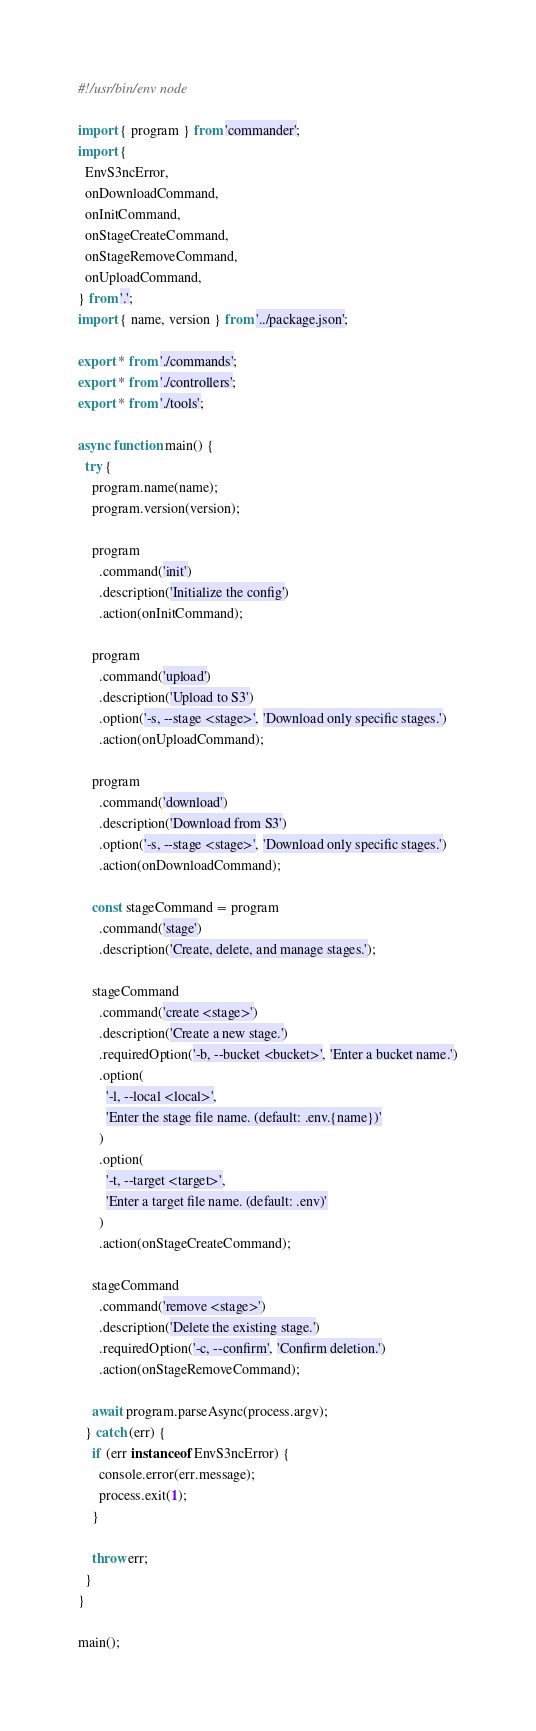Convert code to text. <code><loc_0><loc_0><loc_500><loc_500><_TypeScript_>#!/usr/bin/env node

import { program } from 'commander';
import {
  EnvS3ncError,
  onDownloadCommand,
  onInitCommand,
  onStageCreateCommand,
  onStageRemoveCommand,
  onUploadCommand,
} from '.';
import { name, version } from '../package.json';

export * from './commands';
export * from './controllers';
export * from './tools';

async function main() {
  try {
    program.name(name);
    program.version(version);

    program
      .command('init')
      .description('Initialize the config')
      .action(onInitCommand);

    program
      .command('upload')
      .description('Upload to S3')
      .option('-s, --stage <stage>', 'Download only specific stages.')
      .action(onUploadCommand);

    program
      .command('download')
      .description('Download from S3')
      .option('-s, --stage <stage>', 'Download only specific stages.')
      .action(onDownloadCommand);

    const stageCommand = program
      .command('stage')
      .description('Create, delete, and manage stages.');

    stageCommand
      .command('create <stage>')
      .description('Create a new stage.')
      .requiredOption('-b, --bucket <bucket>', 'Enter a bucket name.')
      .option(
        '-l, --local <local>',
        'Enter the stage file name. (default: .env.{name})'
      )
      .option(
        '-t, --target <target>',
        'Enter a target file name. (default: .env)'
      )
      .action(onStageCreateCommand);

    stageCommand
      .command('remove <stage>')
      .description('Delete the existing stage.')
      .requiredOption('-c, --confirm', 'Confirm deletion.')
      .action(onStageRemoveCommand);

    await program.parseAsync(process.argv);
  } catch (err) {
    if (err instanceof EnvS3ncError) {
      console.error(err.message);
      process.exit(1);
    }

    throw err;
  }
}

main();
</code> 